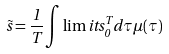<formula> <loc_0><loc_0><loc_500><loc_500>\tilde { s } = \frac { 1 } { T } \int \lim i t s ^ { T } _ { 0 } d \tau \mu ( \tau )</formula> 